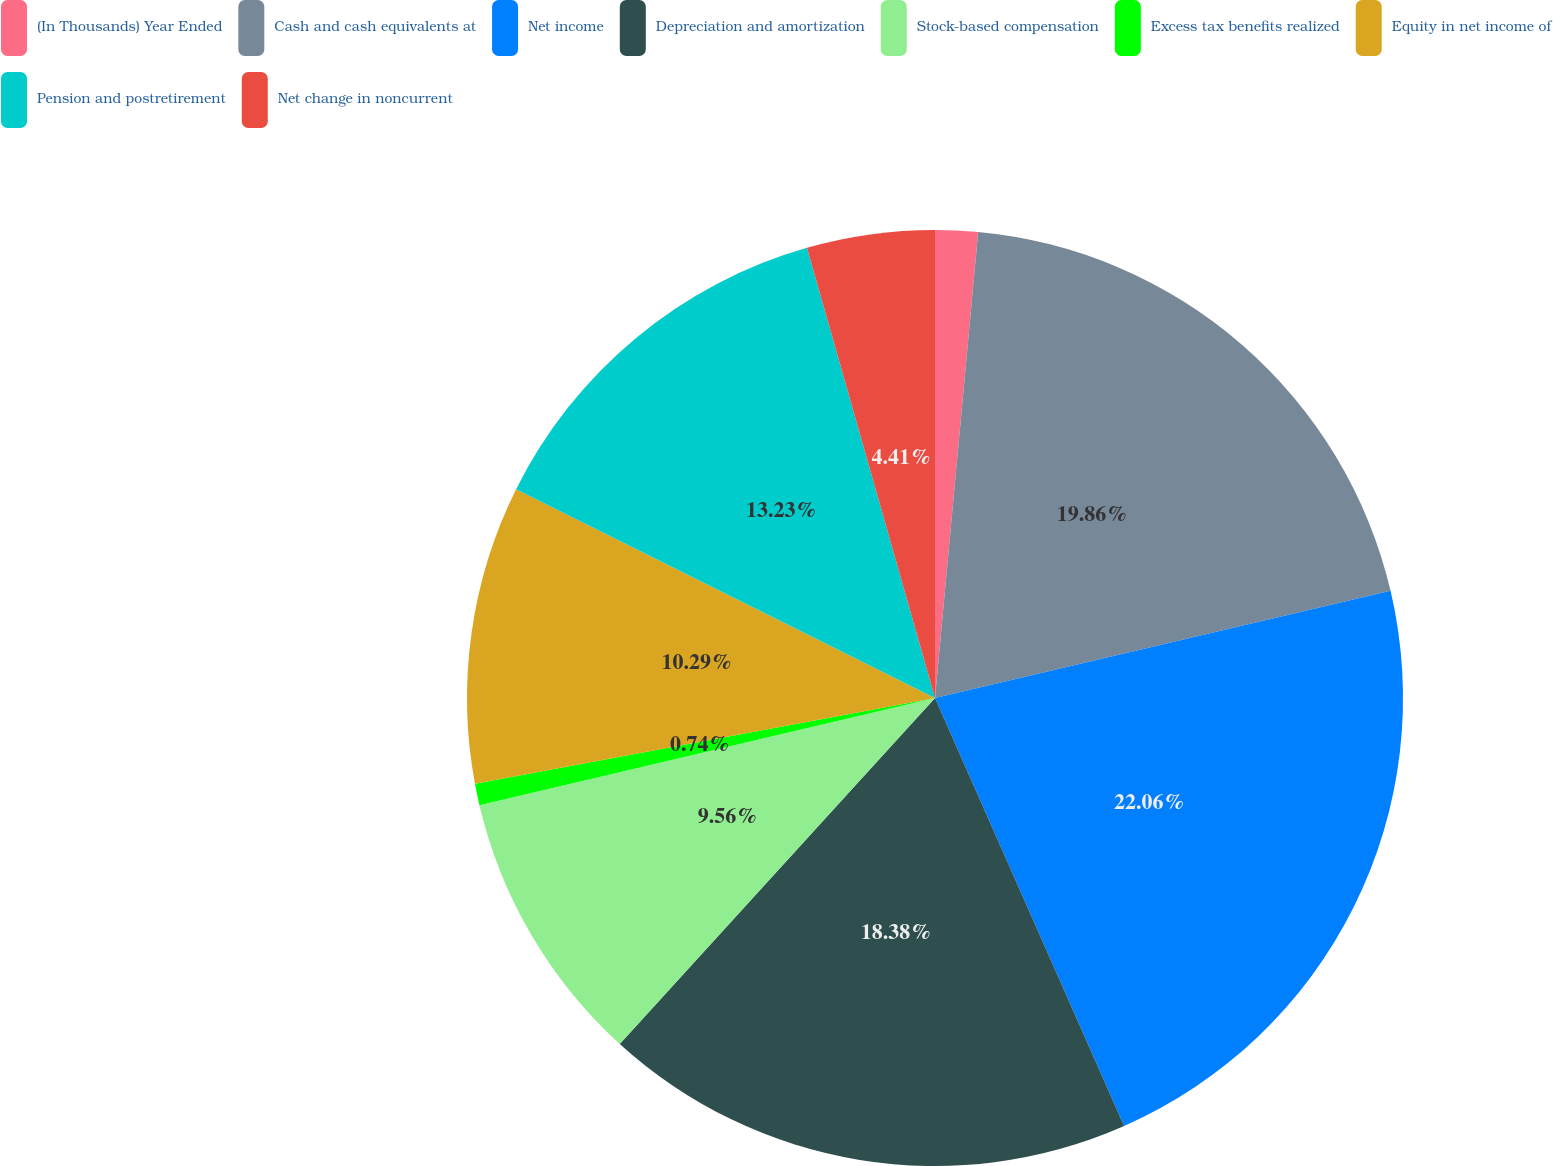Convert chart. <chart><loc_0><loc_0><loc_500><loc_500><pie_chart><fcel>(In Thousands) Year Ended<fcel>Cash and cash equivalents at<fcel>Net income<fcel>Depreciation and amortization<fcel>Stock-based compensation<fcel>Excess tax benefits realized<fcel>Equity in net income of<fcel>Pension and postretirement<fcel>Net change in noncurrent<nl><fcel>1.47%<fcel>19.85%<fcel>22.05%<fcel>18.38%<fcel>9.56%<fcel>0.74%<fcel>10.29%<fcel>13.23%<fcel>4.41%<nl></chart> 